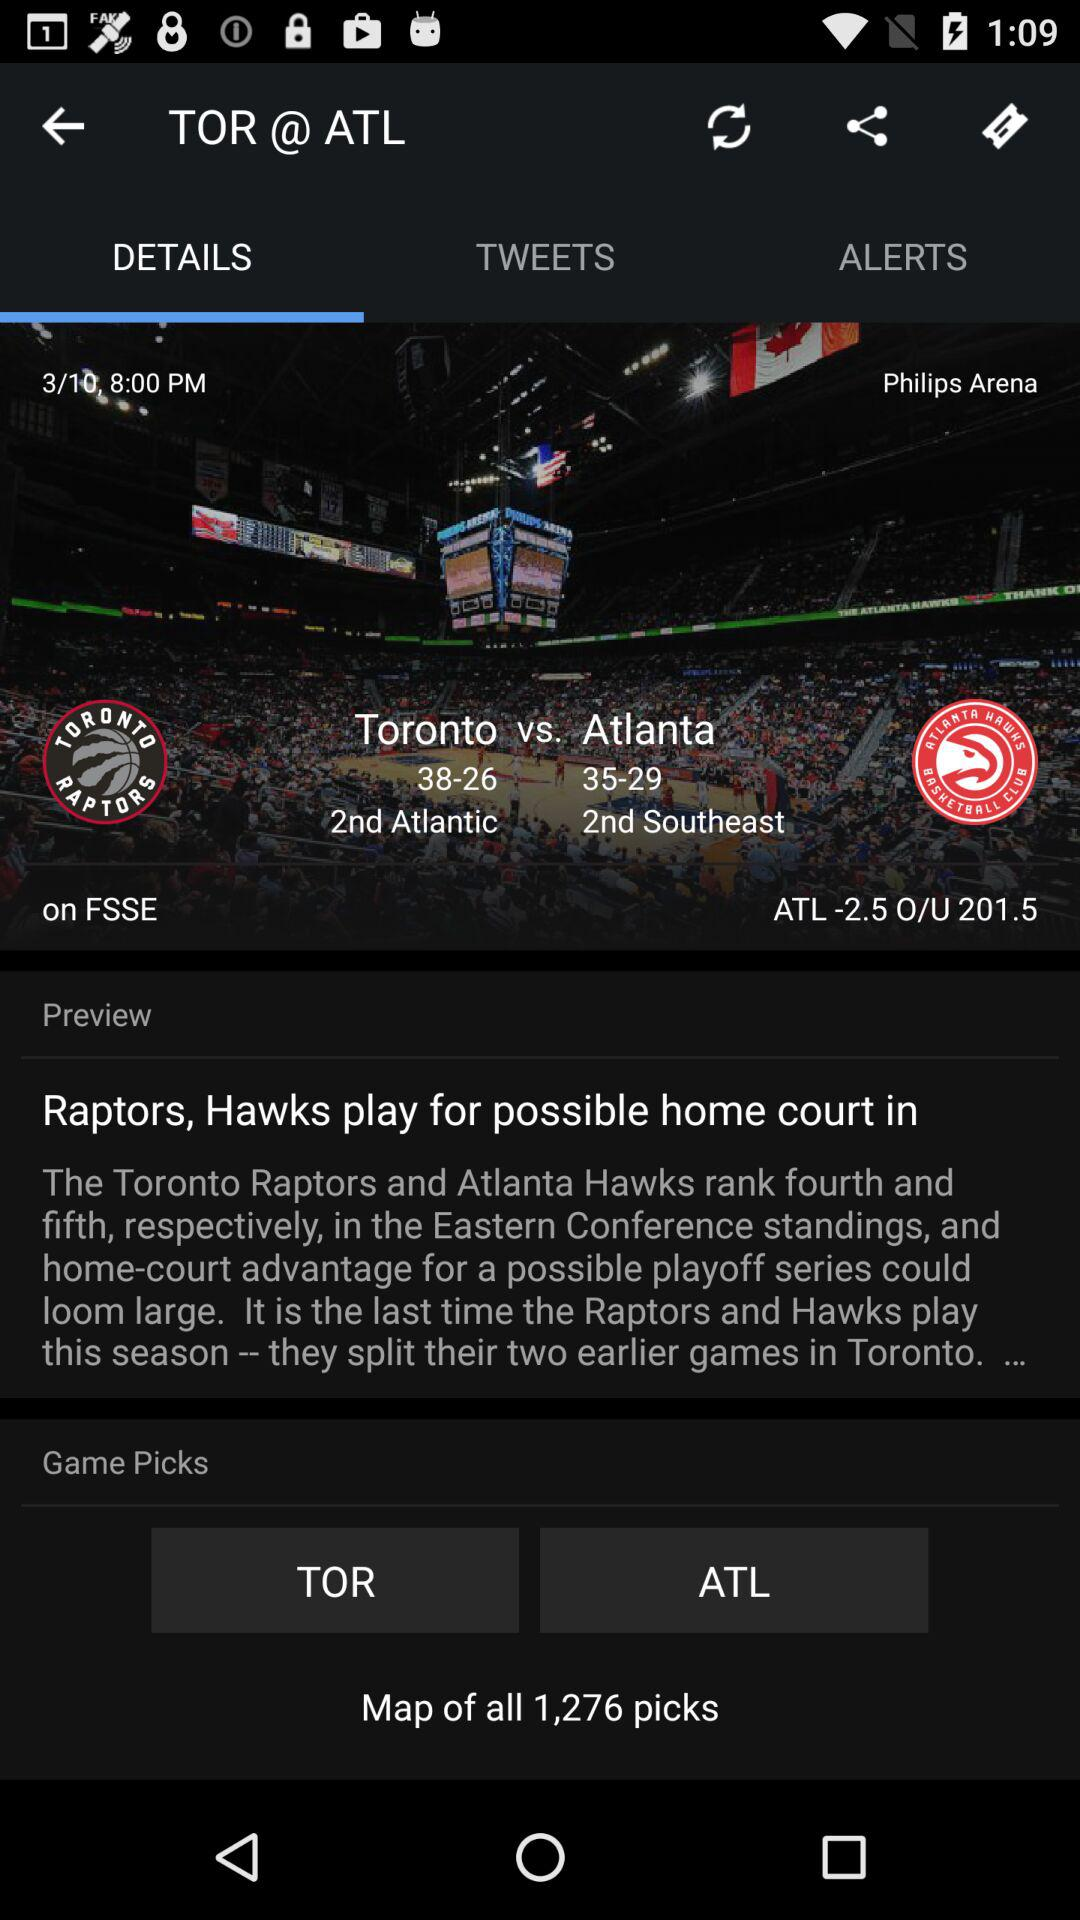What is the time and date? The time is 8 p.m. and the date is March 10. 